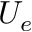Convert formula to latex. <formula><loc_0><loc_0><loc_500><loc_500>U _ { e }</formula> 